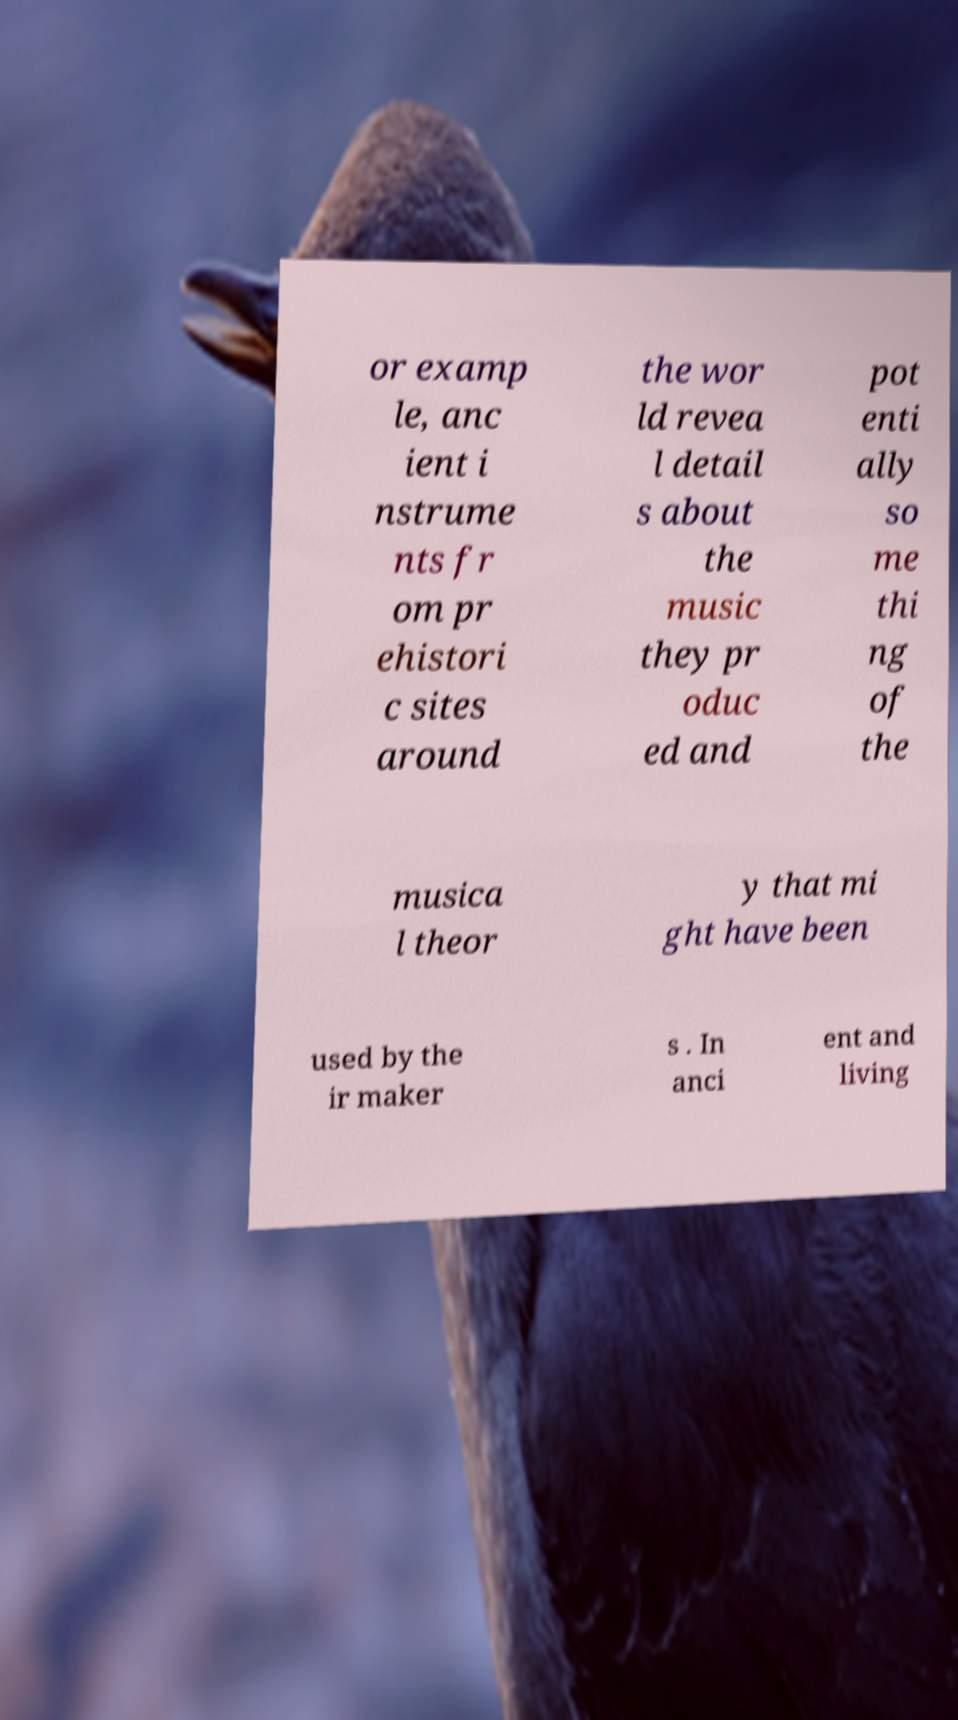Please read and relay the text visible in this image. What does it say? or examp le, anc ient i nstrume nts fr om pr ehistori c sites around the wor ld revea l detail s about the music they pr oduc ed and pot enti ally so me thi ng of the musica l theor y that mi ght have been used by the ir maker s . In anci ent and living 